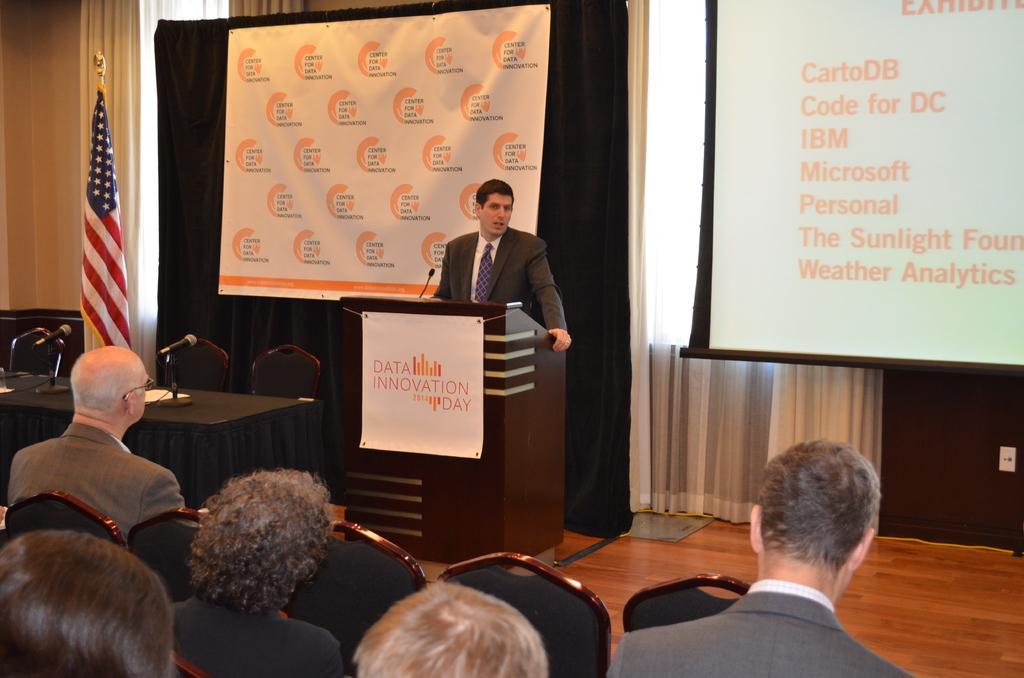How would you summarize this image in a sentence or two? At the bottom I can see a group of people are sitting on the chairs, a table on which mikes are there. In the middle I can see a person is standing in front of a table. In the background I can see a screen, flag and a curtain. This image is taken in a hall. 